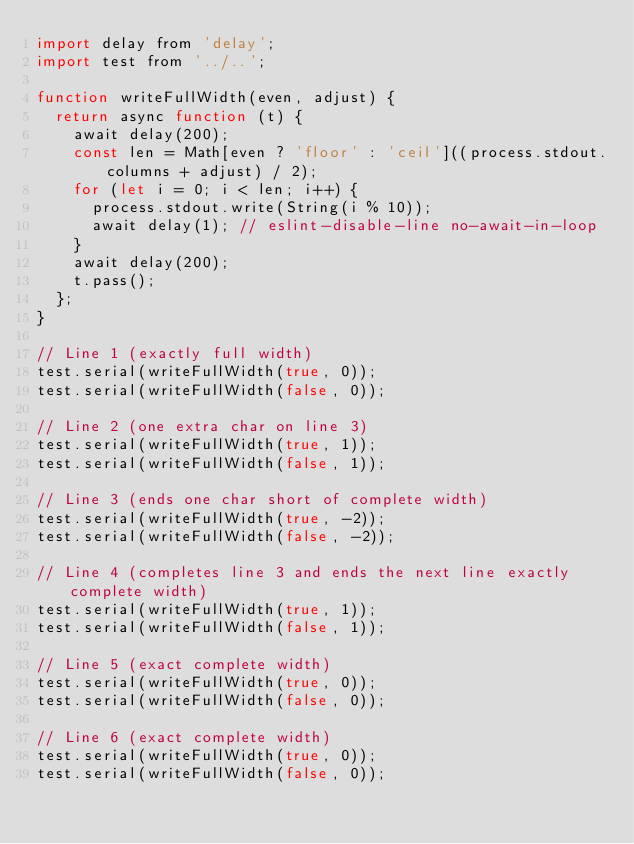<code> <loc_0><loc_0><loc_500><loc_500><_JavaScript_>import delay from 'delay';
import test from '../..';

function writeFullWidth(even, adjust) {
	return async function (t) {
		await delay(200);
		const len = Math[even ? 'floor' : 'ceil']((process.stdout.columns + adjust) / 2);
		for (let i = 0; i < len; i++) {
			process.stdout.write(String(i % 10));
			await delay(1); // eslint-disable-line no-await-in-loop
		}
		await delay(200);
		t.pass();
	};
}

// Line 1 (exactly full width)
test.serial(writeFullWidth(true, 0));
test.serial(writeFullWidth(false, 0));

// Line 2 (one extra char on line 3)
test.serial(writeFullWidth(true, 1));
test.serial(writeFullWidth(false, 1));

// Line 3 (ends one char short of complete width)
test.serial(writeFullWidth(true, -2));
test.serial(writeFullWidth(false, -2));

// Line 4 (completes line 3 and ends the next line exactly complete width)
test.serial(writeFullWidth(true, 1));
test.serial(writeFullWidth(false, 1));

// Line 5 (exact complete width)
test.serial(writeFullWidth(true, 0));
test.serial(writeFullWidth(false, 0));

// Line 6 (exact complete width)
test.serial(writeFullWidth(true, 0));
test.serial(writeFullWidth(false, 0));
</code> 